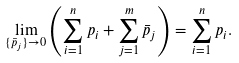Convert formula to latex. <formula><loc_0><loc_0><loc_500><loc_500>\lim _ { \{ \bar { p } _ { j } \} \to 0 } \left ( \sum _ { i = 1 } ^ { n } p _ { i } + \sum _ { j = 1 } ^ { m } \bar { p } _ { j } \right ) = \sum _ { i = 1 } ^ { n } p _ { i } .</formula> 